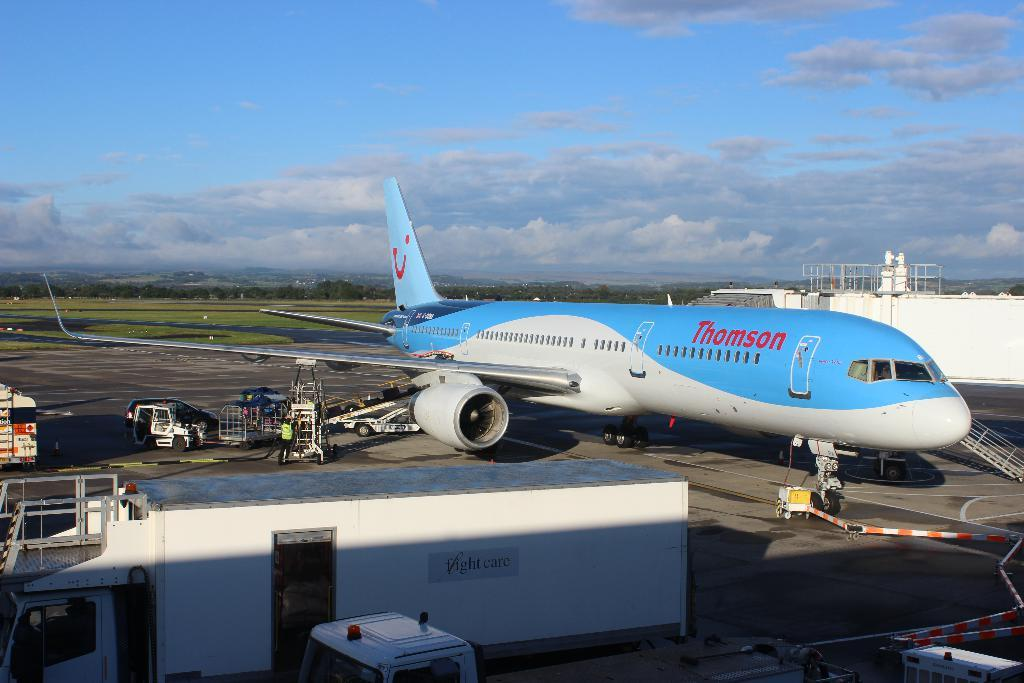<image>
Create a compact narrative representing the image presented. An airplane from the company Thomson on the ground 